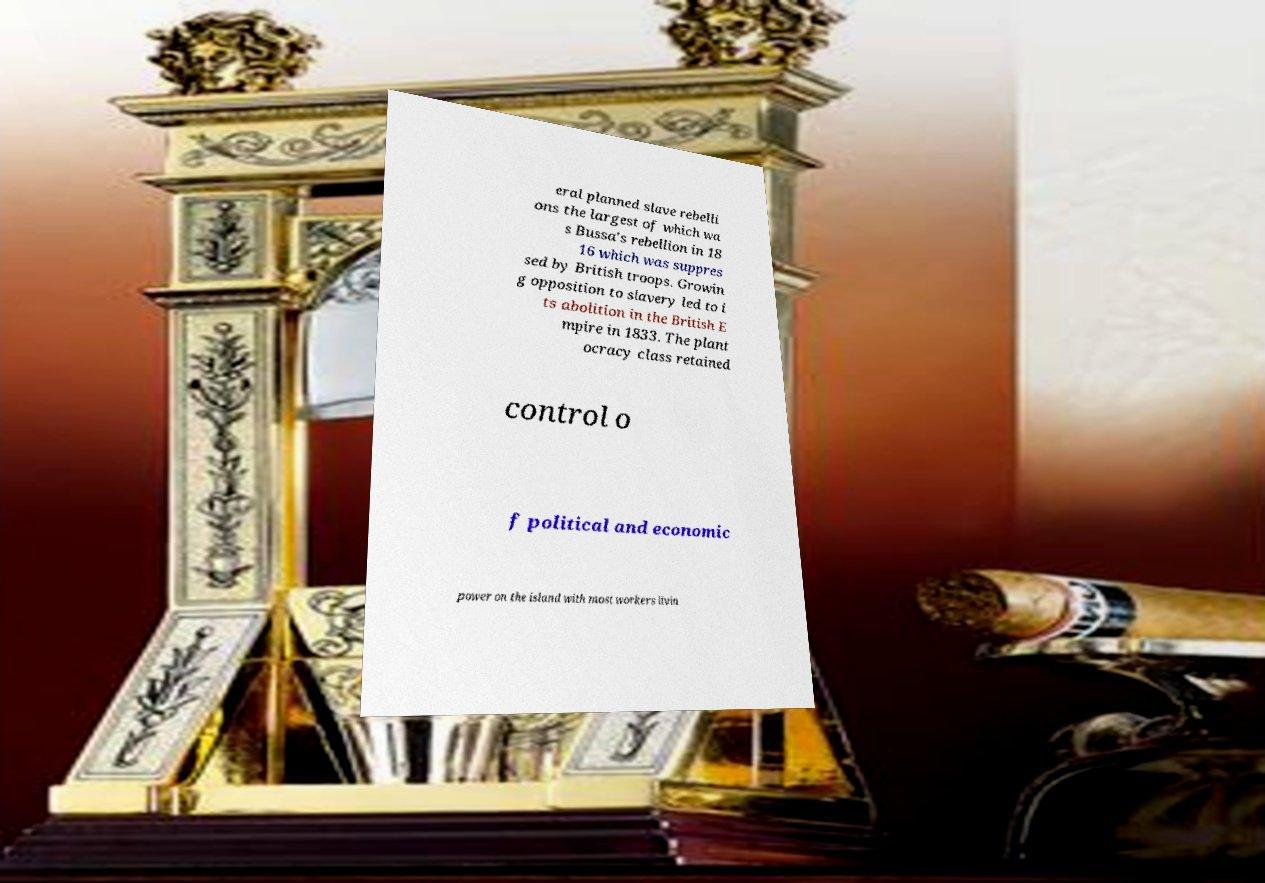Could you assist in decoding the text presented in this image and type it out clearly? eral planned slave rebelli ons the largest of which wa s Bussa's rebellion in 18 16 which was suppres sed by British troops. Growin g opposition to slavery led to i ts abolition in the British E mpire in 1833. The plant ocracy class retained control o f political and economic power on the island with most workers livin 